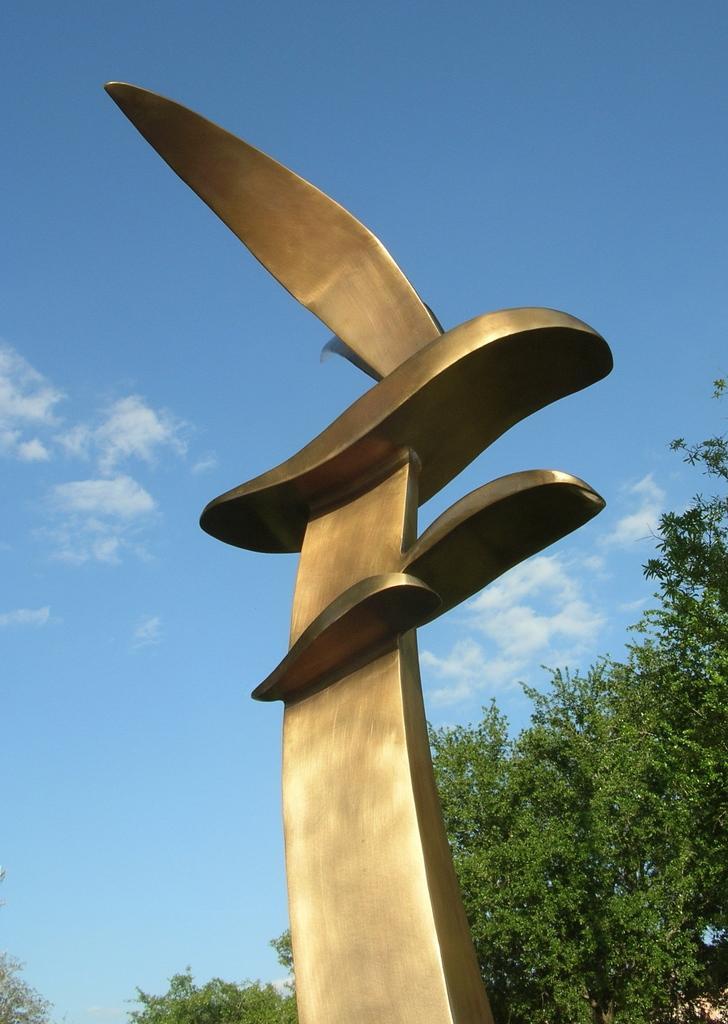How would you summarize this image in a sentence or two? In the middle of this image, there is a statue. In the background, there are trees and there are clouds in the blue sky. 